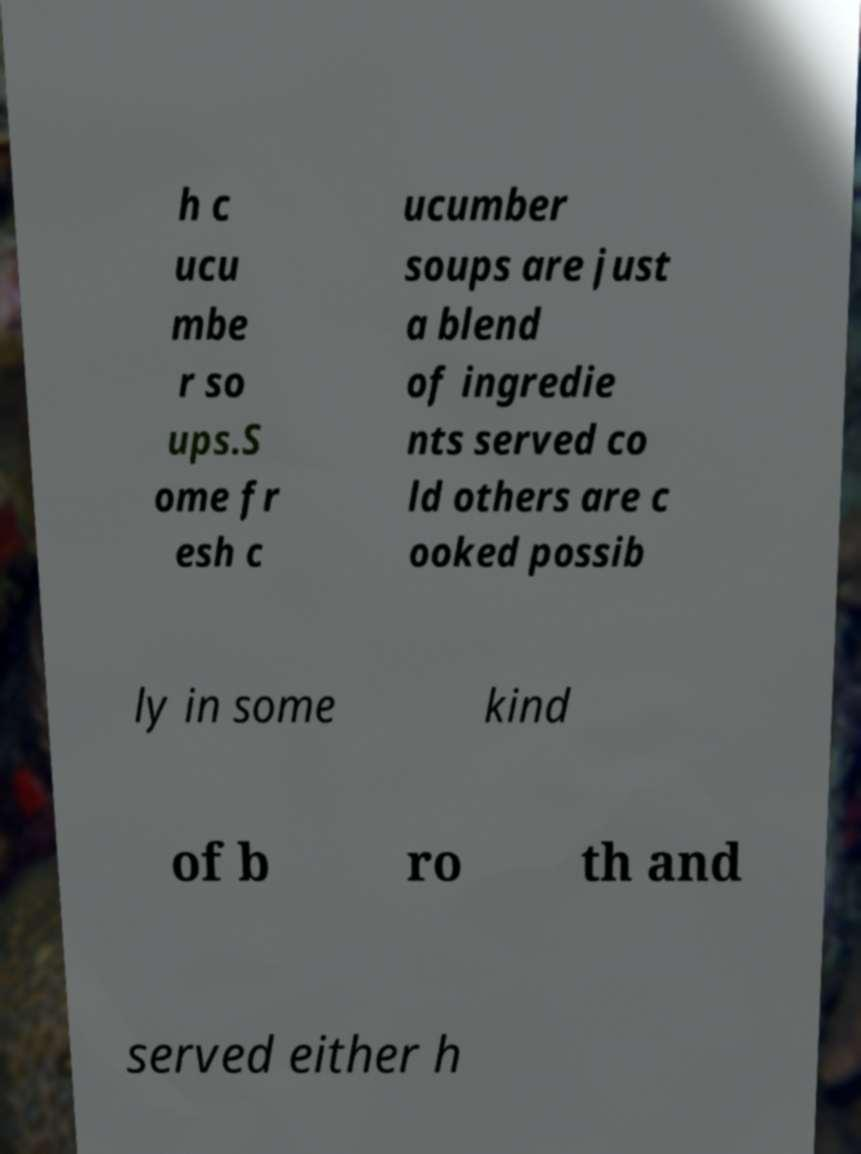Can you accurately transcribe the text from the provided image for me? h c ucu mbe r so ups.S ome fr esh c ucumber soups are just a blend of ingredie nts served co ld others are c ooked possib ly in some kind of b ro th and served either h 